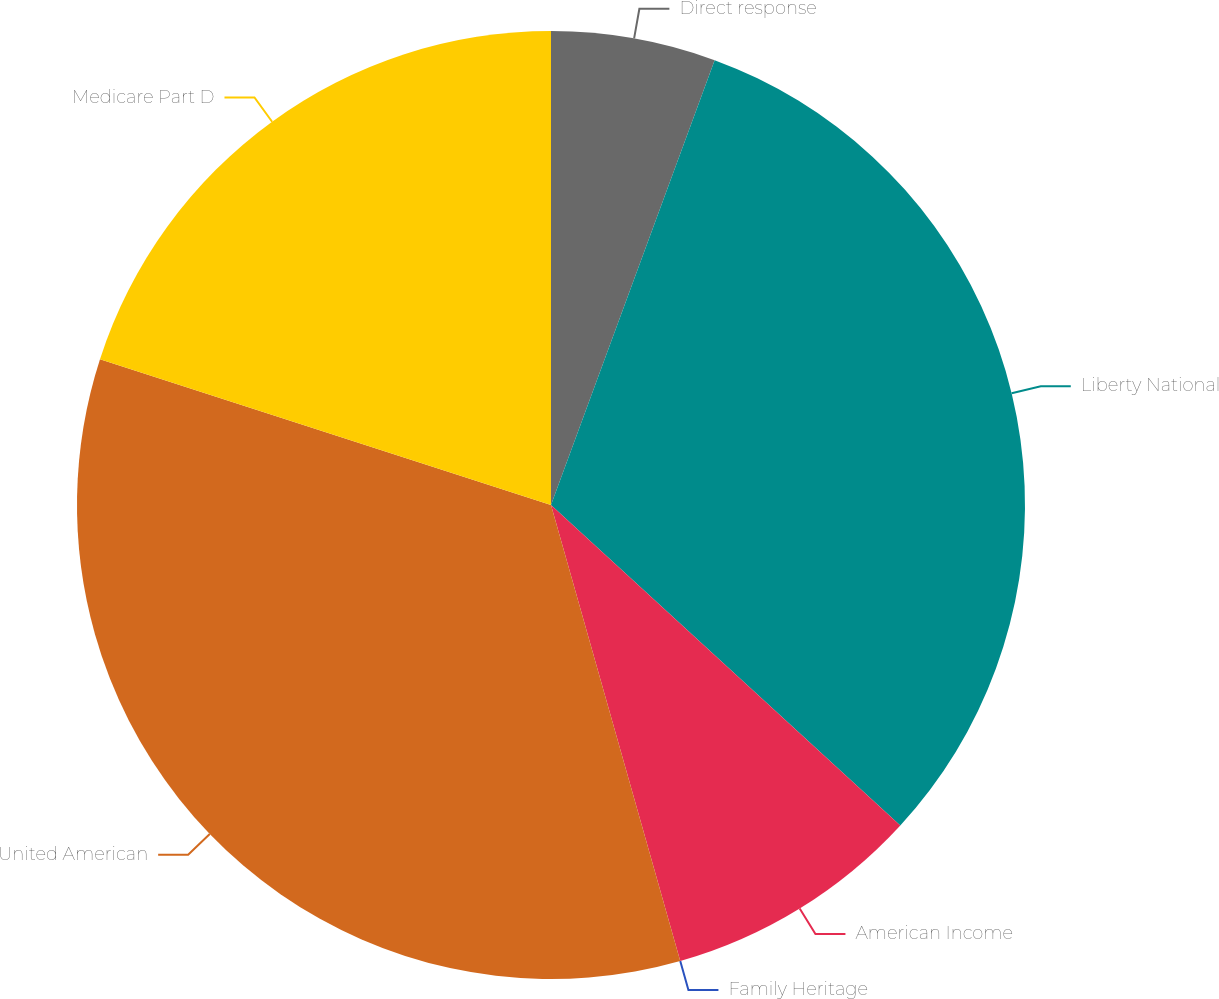Convert chart. <chart><loc_0><loc_0><loc_500><loc_500><pie_chart><fcel>Direct response<fcel>Liberty National<fcel>American Income<fcel>Family Heritage<fcel>United American<fcel>Medicare Part D<nl><fcel>5.61%<fcel>31.2%<fcel>8.79%<fcel>0.0%<fcel>34.37%<fcel>20.02%<nl></chart> 